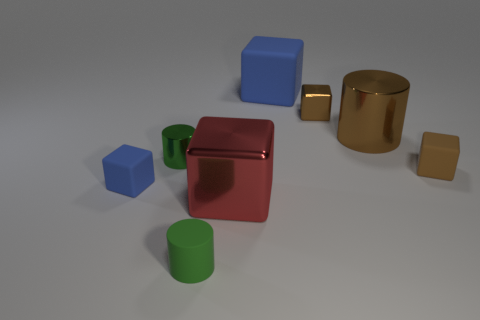Subtract all small brown matte blocks. How many blocks are left? 4 Subtract all red cubes. How many cubes are left? 4 Subtract all yellow cubes. Subtract all yellow spheres. How many cubes are left? 5 Add 1 brown metallic cylinders. How many objects exist? 9 Subtract all cylinders. How many objects are left? 5 Add 7 large gray shiny cubes. How many large gray shiny cubes exist? 7 Subtract 0 yellow blocks. How many objects are left? 8 Subtract all tiny green rubber cylinders. Subtract all brown blocks. How many objects are left? 5 Add 2 small green objects. How many small green objects are left? 4 